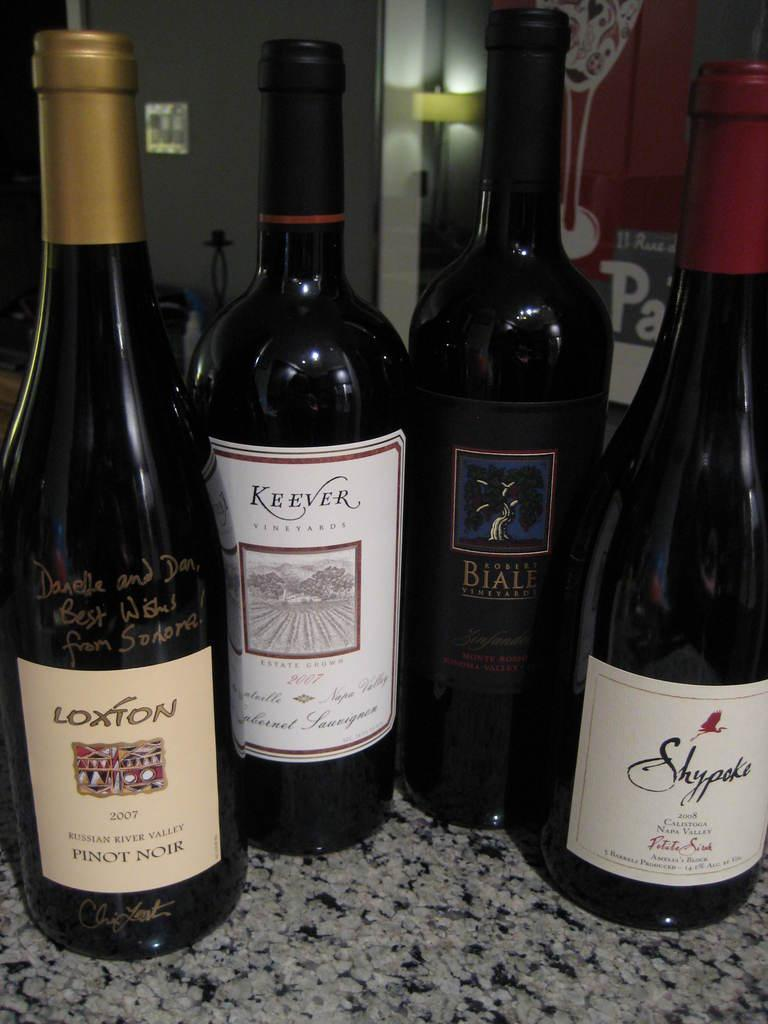<image>
Provide a brief description of the given image. A bottle of Loxton 2007 Russian River Valley Pinot Noir sits on a counter with a bottle of Keever 2007 Cabernet Sauvignon and 2 others. 